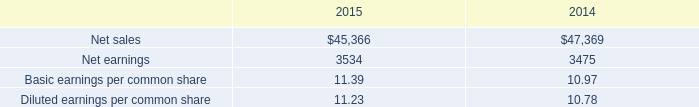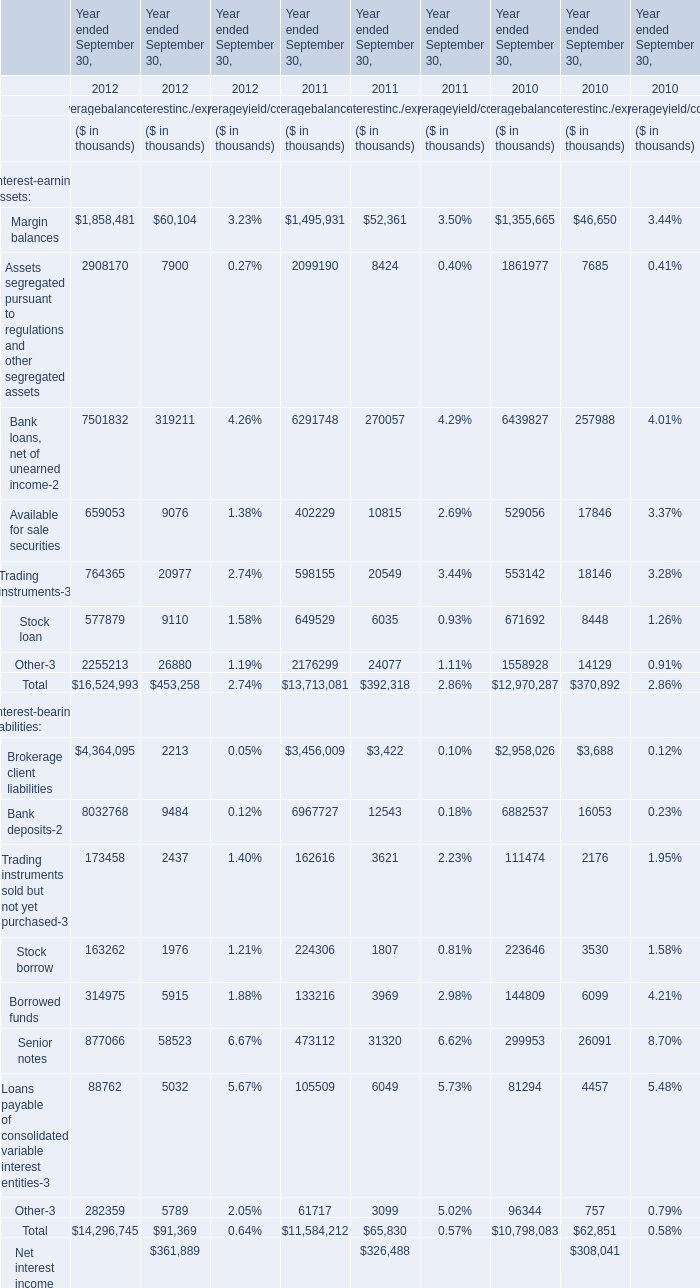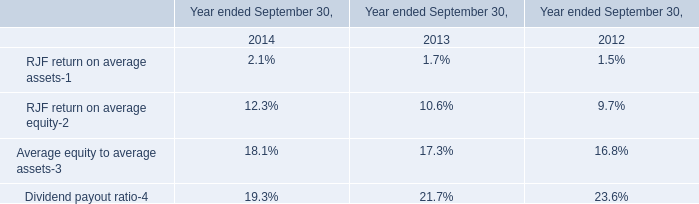How many elements show private value in 2012 for Averagebalance? 
Answer: 17. 